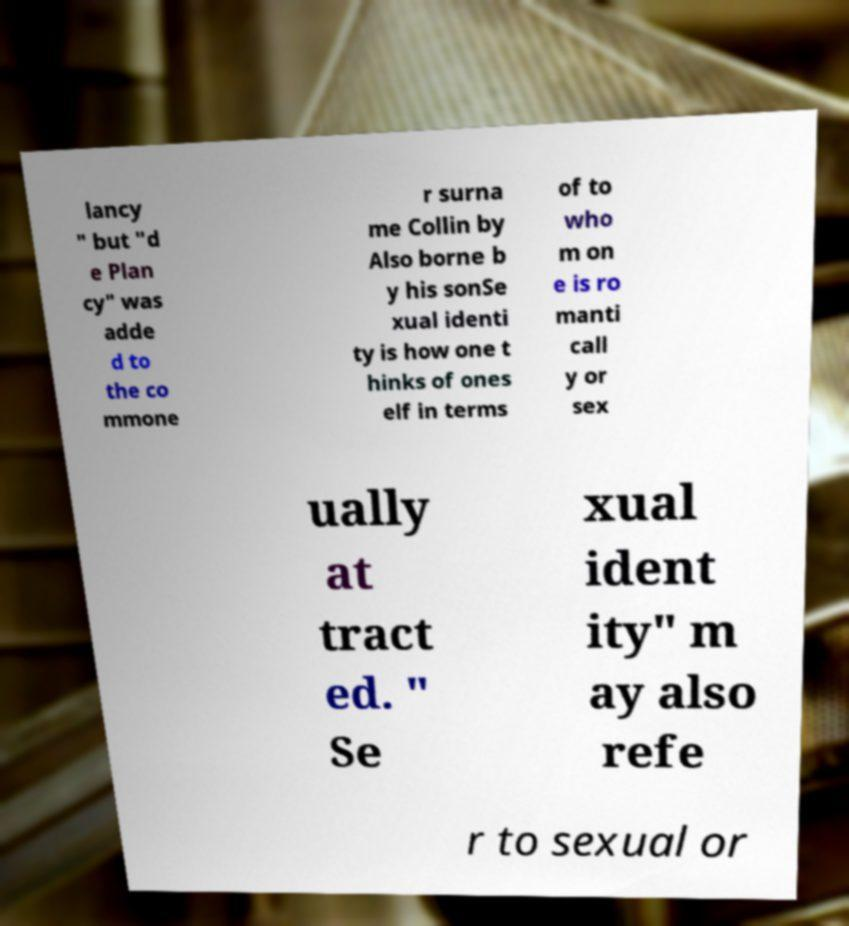There's text embedded in this image that I need extracted. Can you transcribe it verbatim? lancy " but "d e Plan cy" was adde d to the co mmone r surna me Collin by Also borne b y his sonSe xual identi ty is how one t hinks of ones elf in terms of to who m on e is ro manti call y or sex ually at tract ed. " Se xual ident ity" m ay also refe r to sexual or 